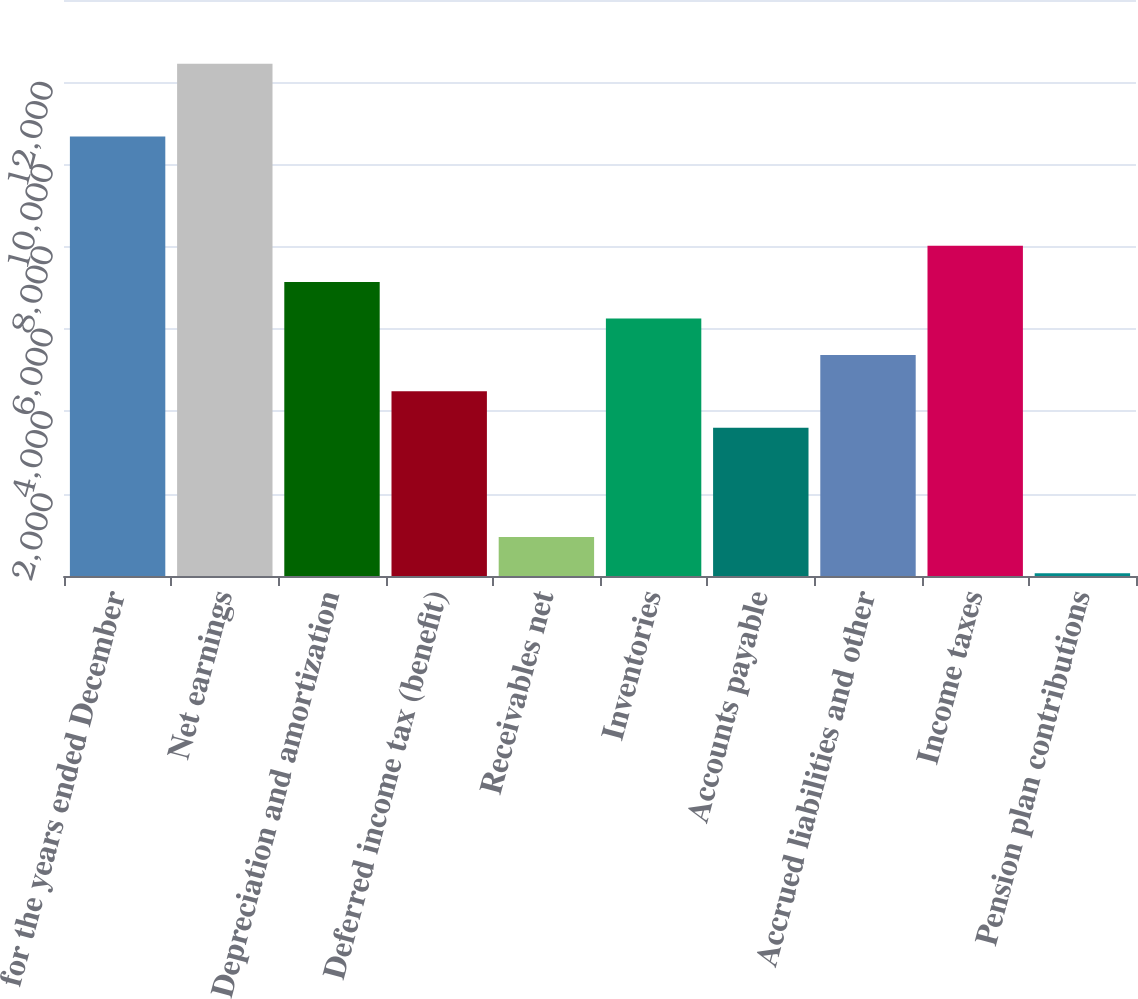Convert chart. <chart><loc_0><loc_0><loc_500><loc_500><bar_chart><fcel>for the years ended December<fcel>Net earnings<fcel>Depreciation and amortization<fcel>Deferred income tax (benefit)<fcel>Receivables net<fcel>Inventories<fcel>Accounts payable<fcel>Accrued liabilities and other<fcel>Income taxes<fcel>Pension plan contributions<nl><fcel>10681.2<fcel>12450.4<fcel>7142.8<fcel>4489<fcel>950.6<fcel>6258.2<fcel>3604.4<fcel>5373.6<fcel>8027.4<fcel>66<nl></chart> 